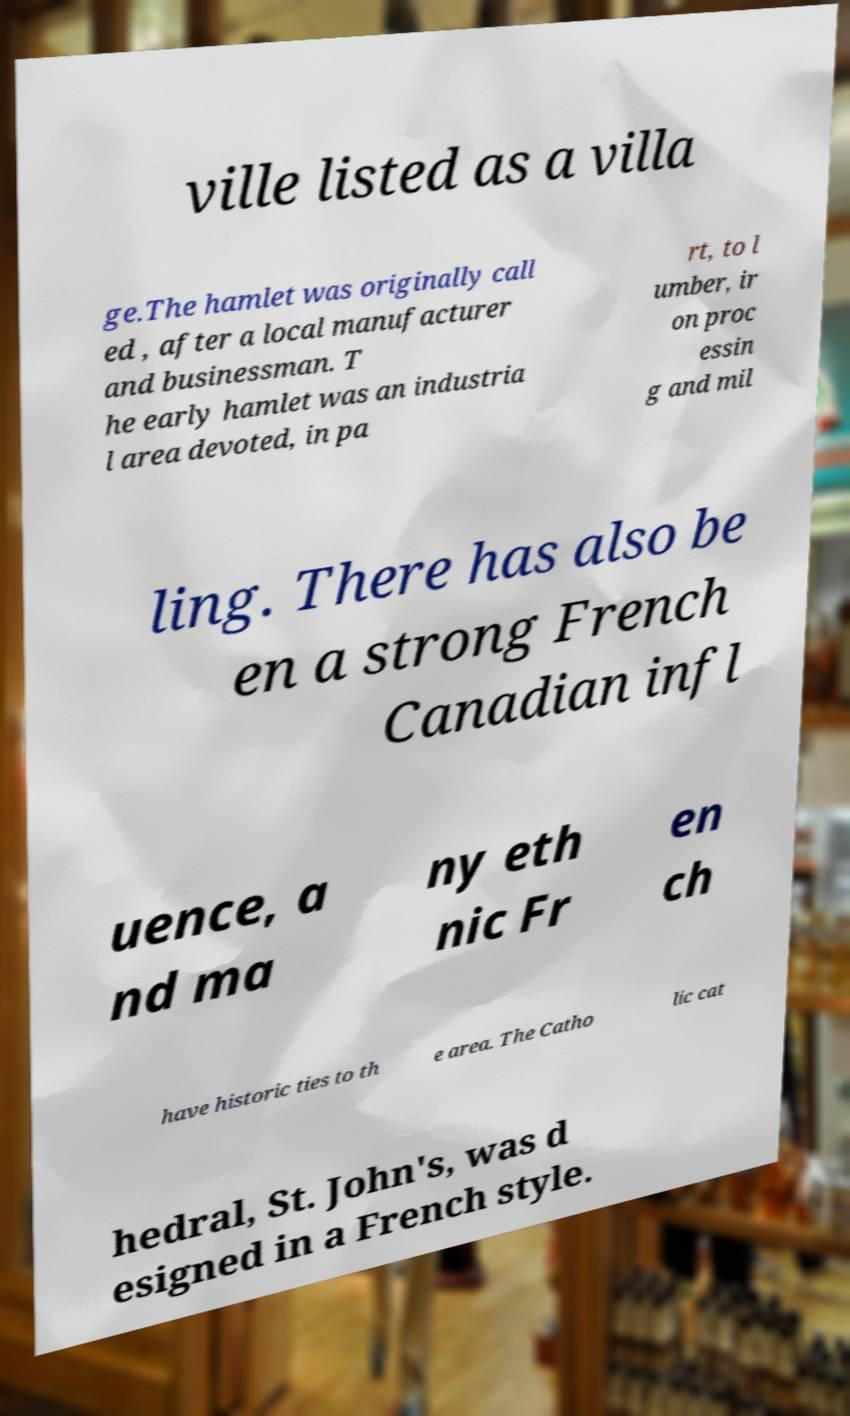Could you assist in decoding the text presented in this image and type it out clearly? ville listed as a villa ge.The hamlet was originally call ed , after a local manufacturer and businessman. T he early hamlet was an industria l area devoted, in pa rt, to l umber, ir on proc essin g and mil ling. There has also be en a strong French Canadian infl uence, a nd ma ny eth nic Fr en ch have historic ties to th e area. The Catho lic cat hedral, St. John's, was d esigned in a French style. 